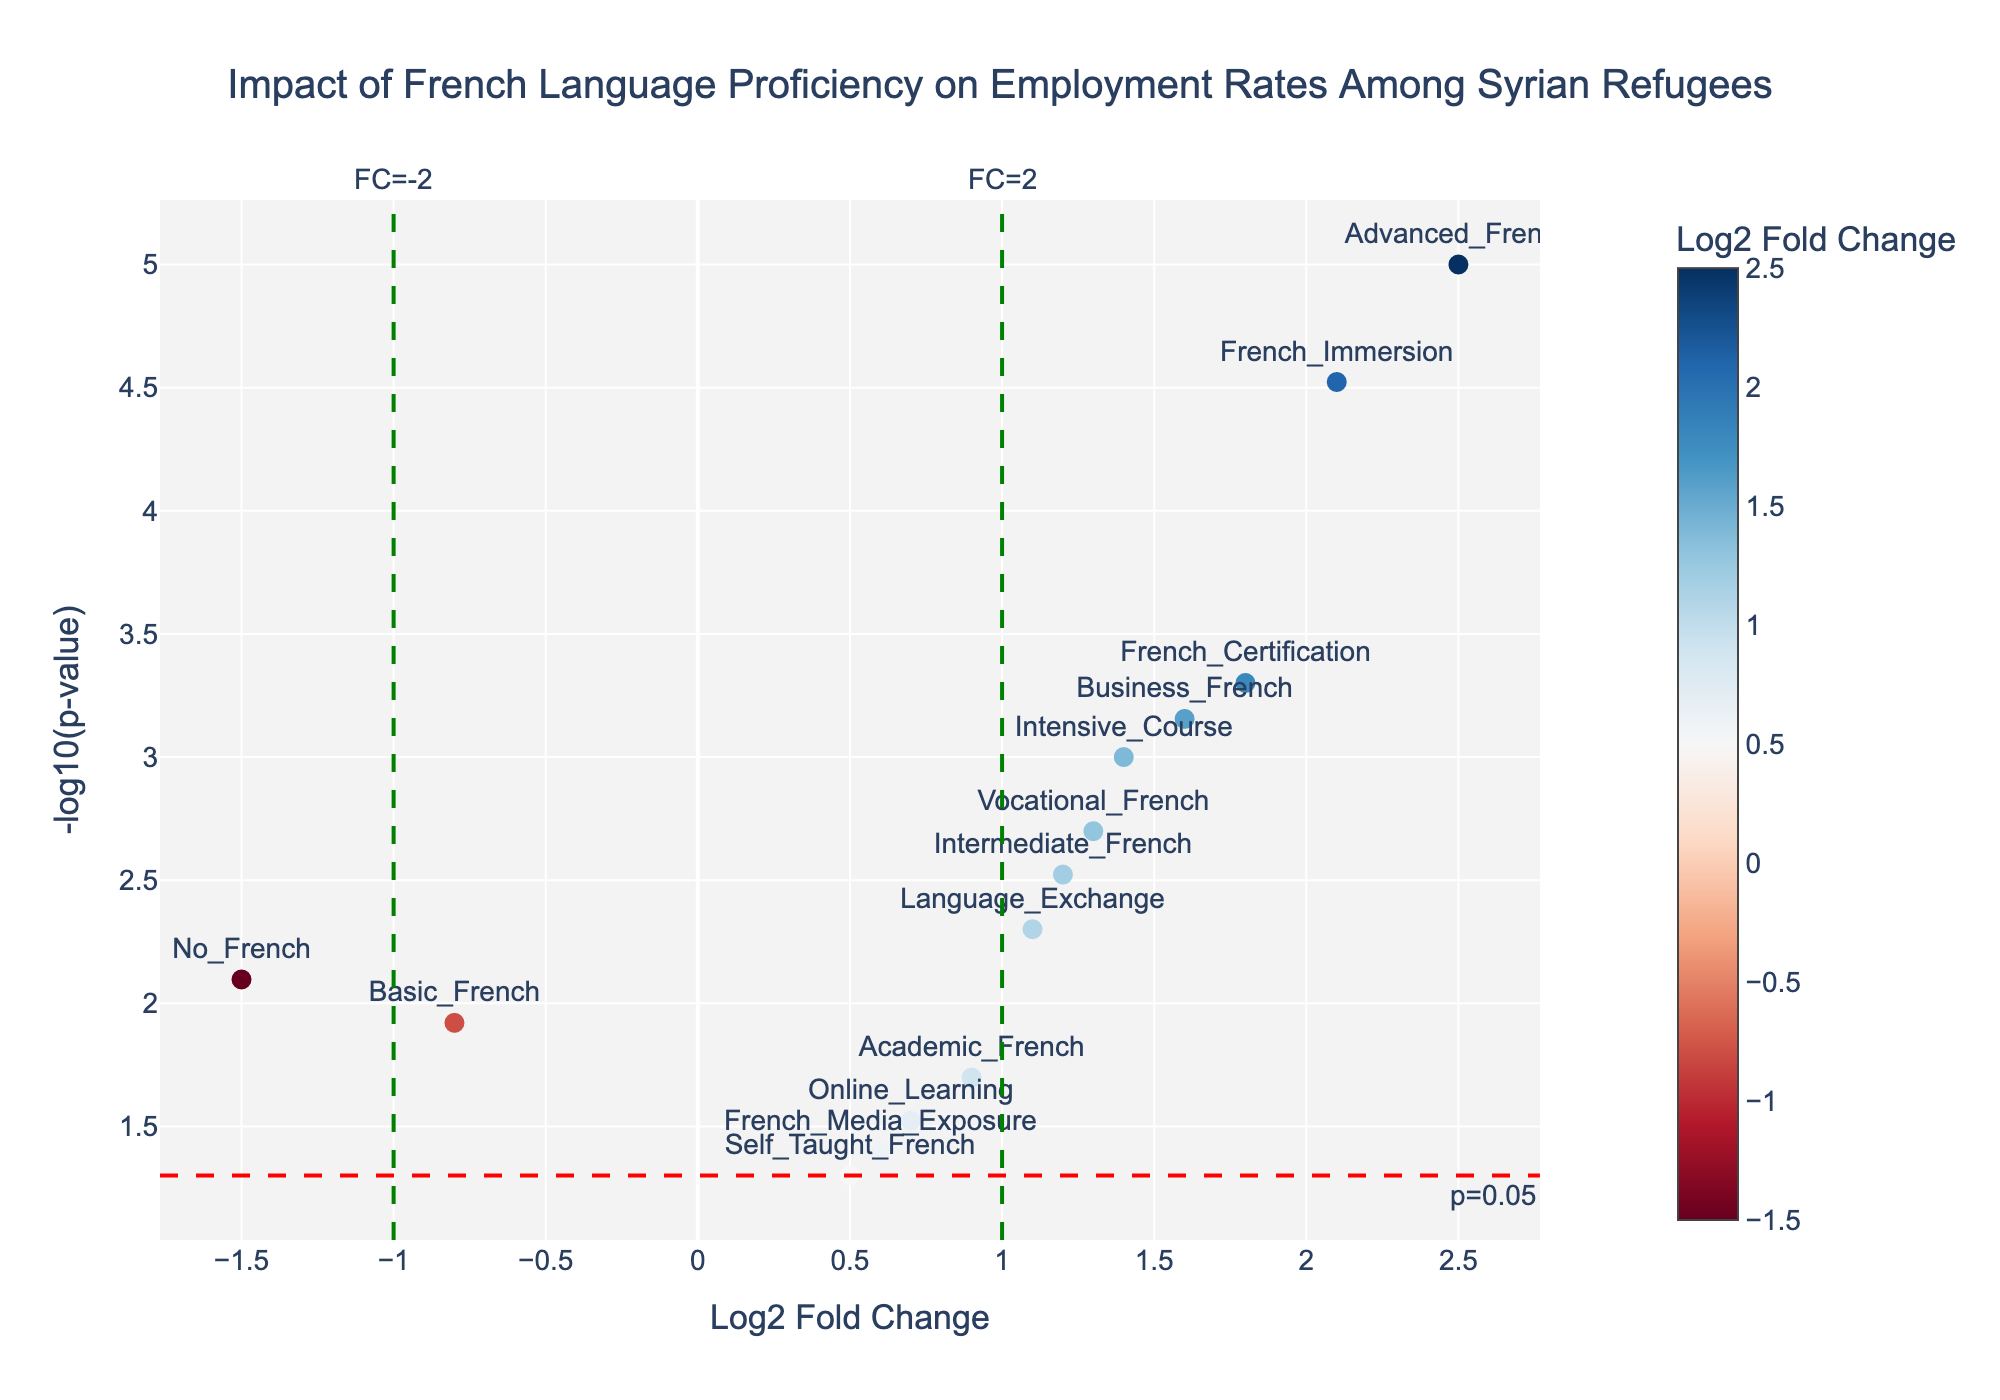What's the title of the figure? The title of the figure is located at the top center of the plot. It reads, "Impact of French Language Proficiency on Employment Rates Among Syrian Refugees".
Answer: Impact of French Language Proficiency on Employment Rates Among Syrian Refugees How many different categories of French language proficiency are represented in the plot? Each marker on the plot represents a different category of French language proficiency. Counting the text labels on the markers, we see there are 14 categories.
Answer: 14 Which category of French language proficiency has the highest Log2 Fold Change? The Log2 Fold Change value is on the x-axis, and the highest value is the furthest right. The marker labeled "Advanced_French" is the furthest right with a Log2 Fold Change of 2.5.
Answer: Advanced_French What does a red horizontal dashed line on the plot indicate? The red horizontal dashed line signifies the p-value threshold, and the annotation "p=0.05" tells us this threshold. It is a line where -log10(p-value) equals approximately 1.3.
Answer: p-value threshold of 0.05 Which category of French language proficiency has the smallest p-value? The y-axis represents the -log10(p-value). The highest point on the y-axis (furthest up) shows the smallest p-value. The marker labeled "Advanced_French" is the highest with a p-value of 0.00001.
Answer: Advanced_French How many categories have statistically significant p-values (p < 0.05)? Statistically significant p-values are above the red horizontal dashed line. Count the markers above this line to find the answer. There are 11 categories above the line.
Answer: 11 Which categories have a Log2 Fold Change less than -1? Categories with Log2 Fold Change less than -1 are found to the left of the green vertical dashed line at x = -1. The markers labeled "No_French" and "Basic_French" fall within this range.
Answer: No_French, Basic_French How does the Log2 Fold Change of "French_Immersion" compare to "French_Certification"? Compare the positions of "French_Immersion" and "French_Certification" on the x-axis. "French_Immersion" has a Log2 Fold Change of 2.1, and "French_Certification" has 1.8.
Answer: French_Immersion is higher What does the color intensity of the markers represent? The color intensity of the markers corresponds to the Log2 Fold Change. This information can be inferred from the color bar legend labeled "Log2 Fold Change" next to the plot.
Answer: Log2 Fold Change Is "Self_Taught_French" statistically significant? Check if "Self_Taught_French" is above the red horizontal dashed line denoting p = 0.05. It is below the line, indicating it is not statistically significant.
Answer: No 